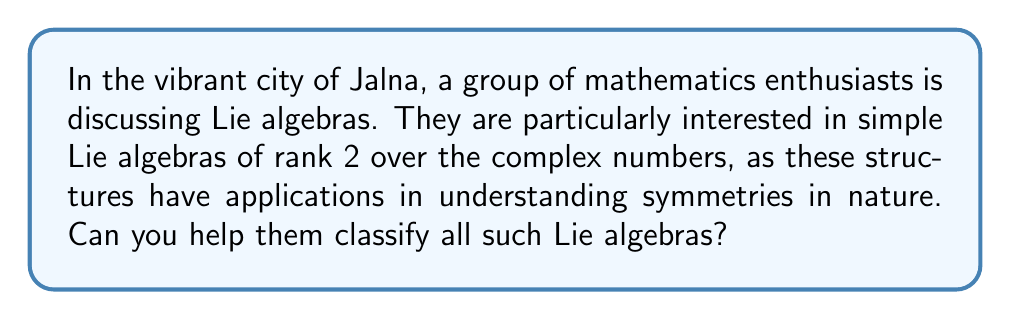Help me with this question. To classify the simple Lie algebras of rank 2 over the complex numbers, we need to follow these steps:

1) Recall that the rank of a Lie algebra is the dimension of its Cartan subalgebra.

2) For simple Lie algebras of rank 2, we need to consider the possible Dynkin diagrams with 2 nodes.

3) There are three possible Dynkin diagrams for rank 2:

   a) $A_2$: Two nodes connected by a single edge
   b) $B_2$ (equivalent to $C_2$): Two nodes connected by a double edge
   c) $G_2$: Two nodes connected by a triple edge

4) Each of these Dynkin diagrams corresponds to a unique simple Lie algebra:

   a) $A_2$ corresponds to $\mathfrak{sl}(3, \mathbb{C})$, the special linear Lie algebra of 3x3 complex matrices with trace zero.
   
   b) $B_2$ (or $C_2$) corresponds to $\mathfrak{so}(5, \mathbb{C})$, the special orthogonal Lie algebra of 5x5 complex matrices, which is isomorphic to $\mathfrak{sp}(4, \mathbb{C})$, the symplectic Lie algebra of 4x4 complex matrices.
   
   c) $G_2$ corresponds to the exceptional Lie algebra of the same name.

5) These are all the possible simple Lie algebras of rank 2 over the complex numbers.

Therefore, we have a complete classification of the simple Lie algebras of rank 2 over $\mathbb{C}$.
Answer: The simple Lie algebras of rank 2 over the complex numbers are:

1) $\mathfrak{sl}(3, \mathbb{C})$ (type $A_2$)
2) $\mathfrak{so}(5, \mathbb{C}) \cong \mathfrak{sp}(4, \mathbb{C})$ (type $B_2$ or $C_2$)
3) $\mathfrak{g}_2$ (type $G_2$) 